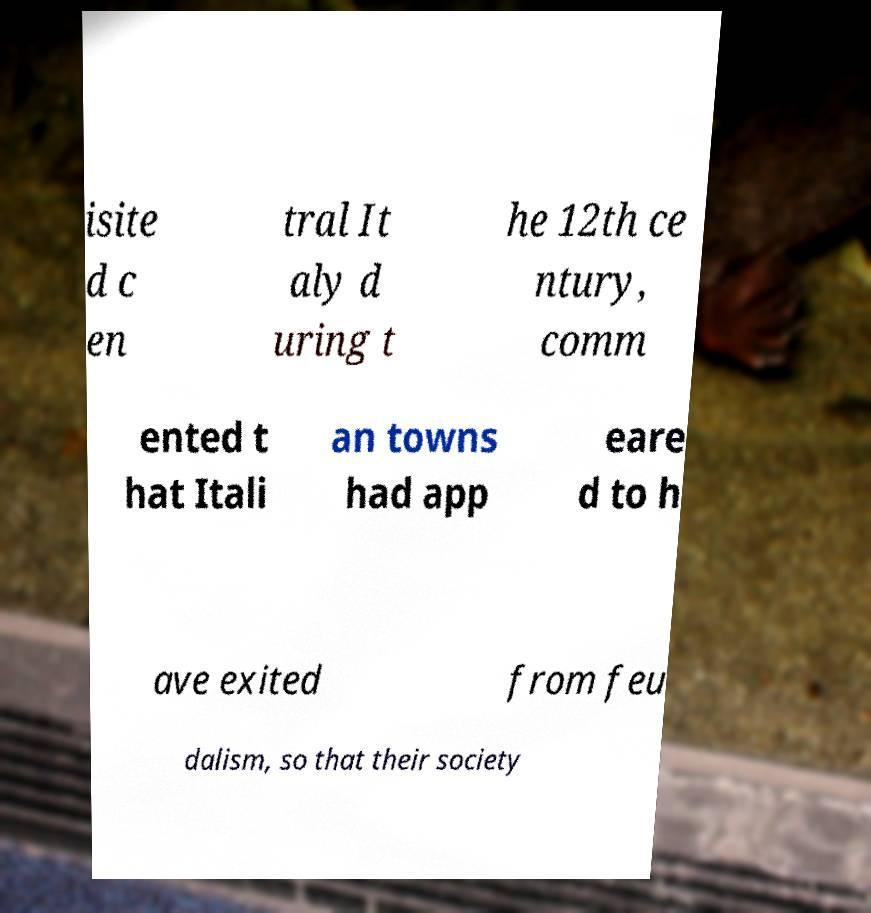Could you assist in decoding the text presented in this image and type it out clearly? isite d c en tral It aly d uring t he 12th ce ntury, comm ented t hat Itali an towns had app eare d to h ave exited from feu dalism, so that their society 